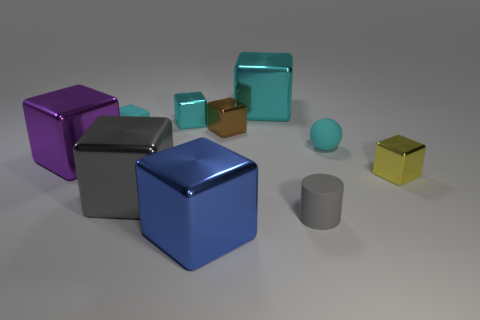Describe the lighting and shadows in the scene. The lighting in the scene appears to be diffused, with soft shadows cast to the right of the objects, suggesting a light source from the left but not directly overhead, creating a calm atmosphere.  What can you infer about the material of the objects? The objects have a reflective surface, suggesting that they could be made of a material like polished metal or plastic with a shiny finish. 